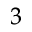Convert formula to latex. <formula><loc_0><loc_0><loc_500><loc_500>^ { 3 }</formula> 